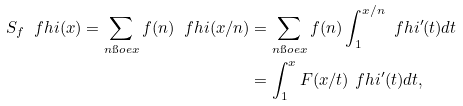<formula> <loc_0><loc_0><loc_500><loc_500>S _ { f } \ f h i ( x ) = \sum _ { n \i o e x } f ( n ) \ f h i ( x / n ) & = \sum _ { n \i o e x } f ( n ) \int _ { 1 } ^ { x / n } \ f h i ^ { \prime } ( t ) d t \\ & = \int _ { 1 } ^ { x } F ( x / t ) \ f h i ^ { \prime } ( t ) d t ,</formula> 